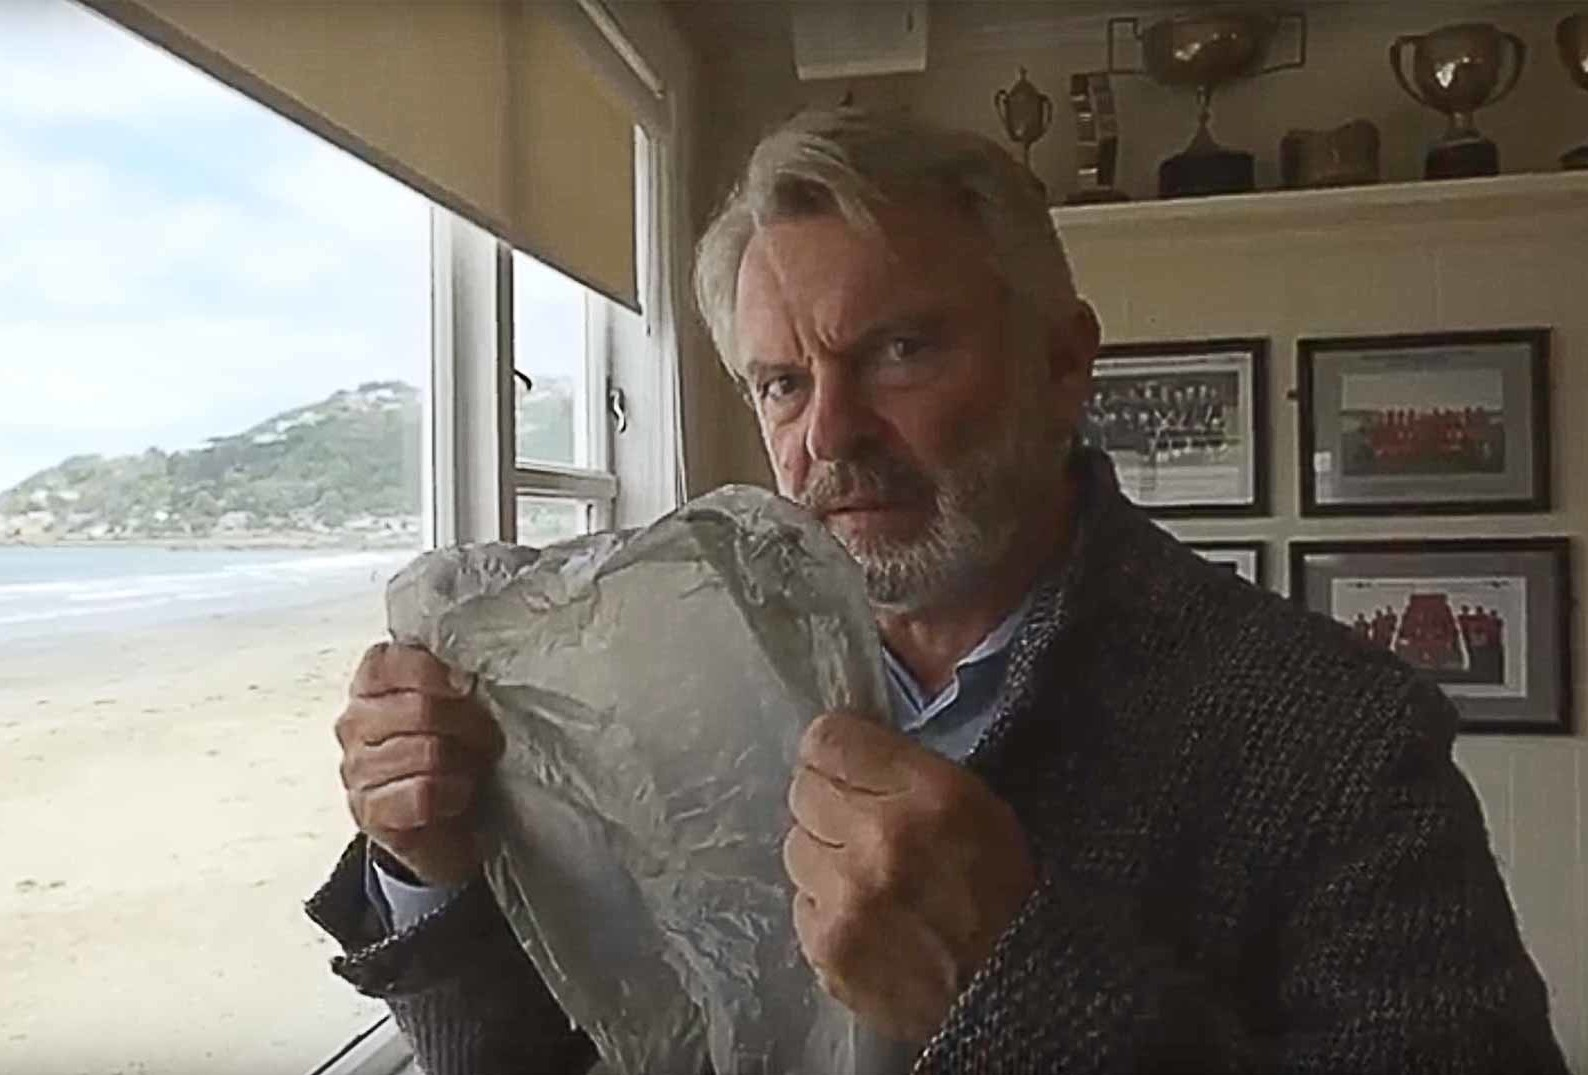What is this photo about? This image captures a man standing by a window overlooking a beach, illuminated by natural light. He is dressed in a cozy sweater and holds a large piece of crumpled aluminum foil, which he presents with a focused and somewhat intense expression. The room suggests a personal space with its collection of framed photos and trophies, indicating achievements or memories of importance. His stance and facial expression seem to convey concentration or deep thought, potentially about a personal project or artistic endeavor. 